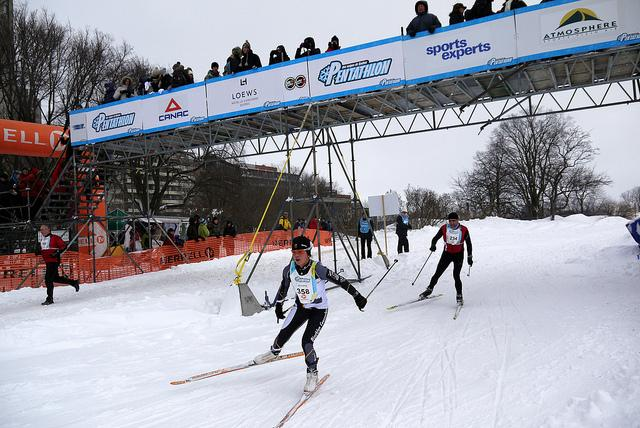What type of signs are shown? Please explain your reasoning. brand. The signs all contain logos of companies and no instructional language like the other options would have had. 